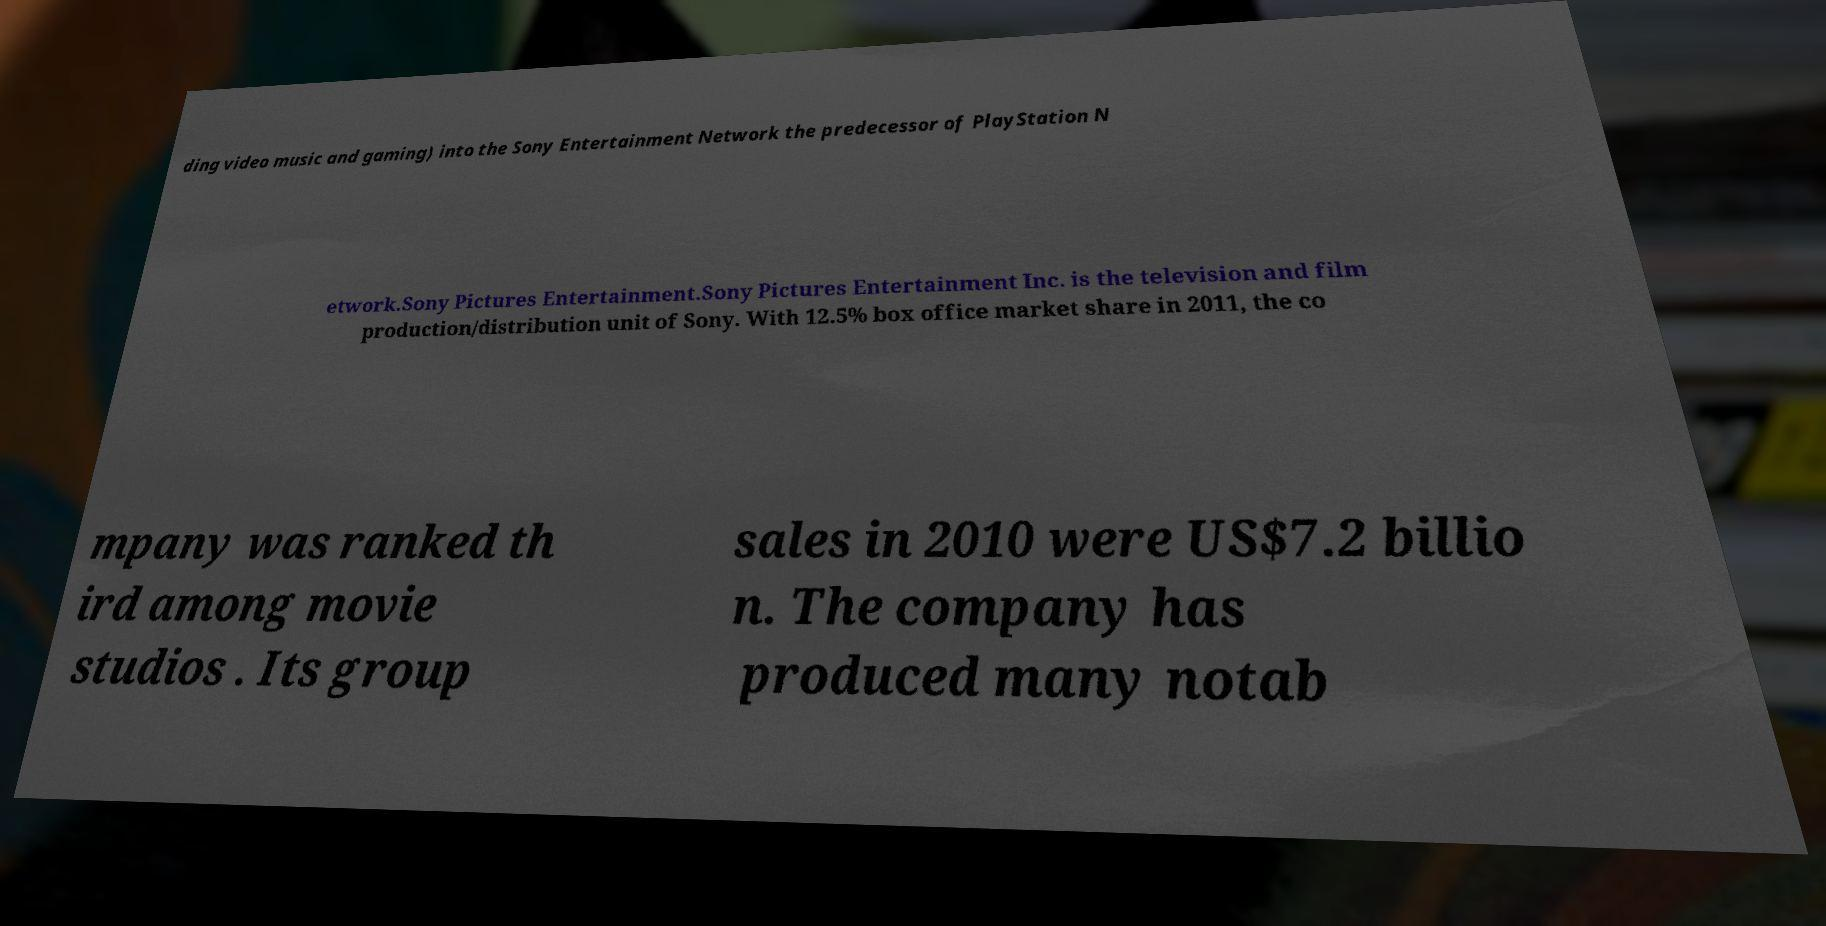What messages or text are displayed in this image? I need them in a readable, typed format. ding video music and gaming) into the Sony Entertainment Network the predecessor of PlayStation N etwork.Sony Pictures Entertainment.Sony Pictures Entertainment Inc. is the television and film production/distribution unit of Sony. With 12.5% box office market share in 2011, the co mpany was ranked th ird among movie studios . Its group sales in 2010 were US$7.2 billio n. The company has produced many notab 